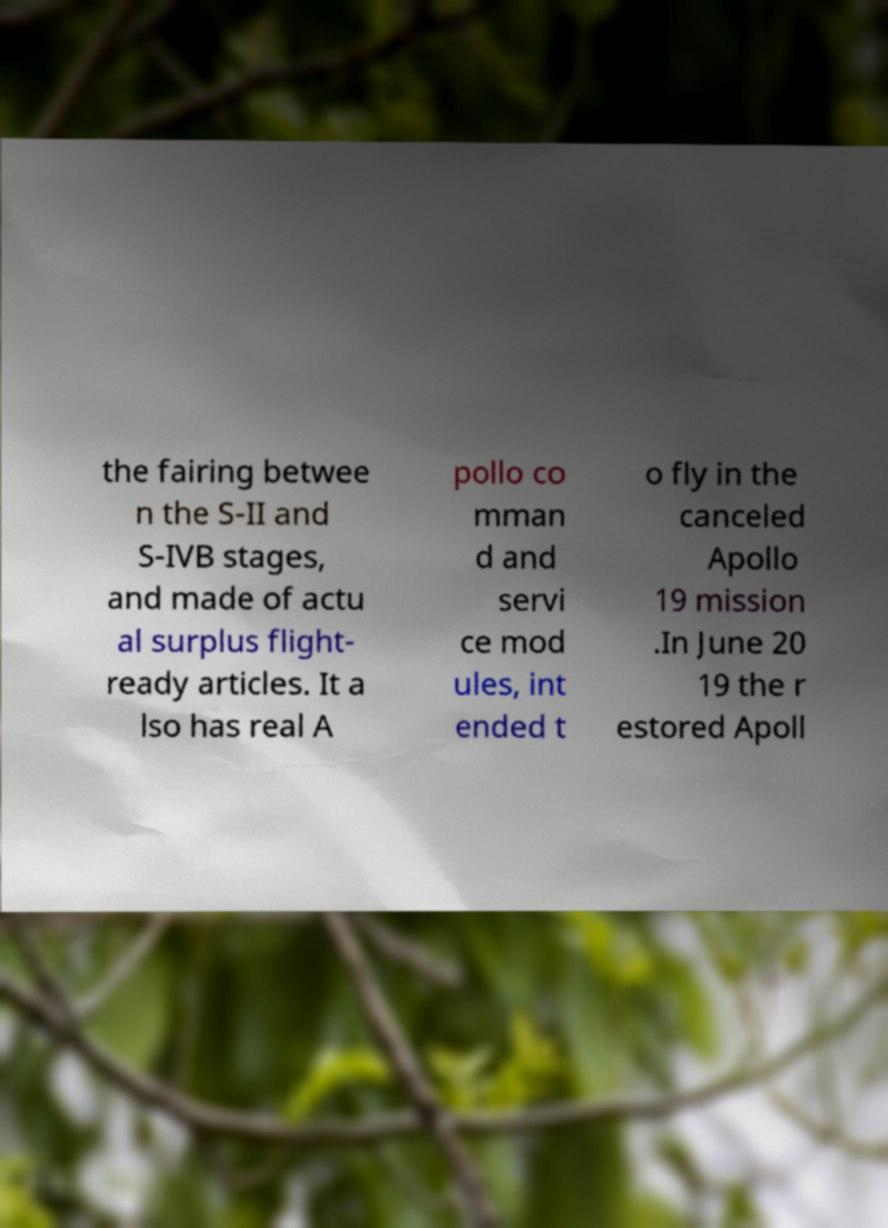I need the written content from this picture converted into text. Can you do that? the fairing betwee n the S-II and S-IVB stages, and made of actu al surplus flight- ready articles. It a lso has real A pollo co mman d and servi ce mod ules, int ended t o fly in the canceled Apollo 19 mission .In June 20 19 the r estored Apoll 